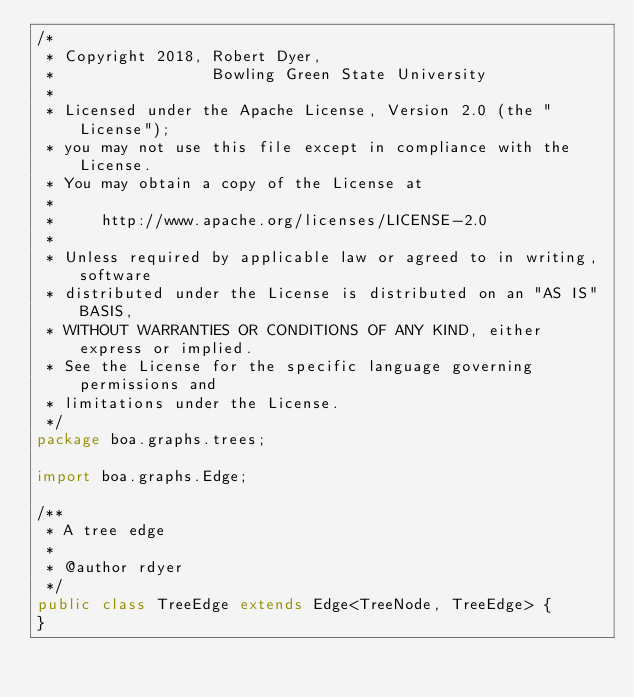<code> <loc_0><loc_0><loc_500><loc_500><_Java_>/*
 * Copyright 2018, Robert Dyer,
 *                 Bowling Green State University
 *
 * Licensed under the Apache License, Version 2.0 (the "License");
 * you may not use this file except in compliance with the License.
 * You may obtain a copy of the License at
 *
 *     http://www.apache.org/licenses/LICENSE-2.0
 *
 * Unless required by applicable law or agreed to in writing, software
 * distributed under the License is distributed on an "AS IS" BASIS,
 * WITHOUT WARRANTIES OR CONDITIONS OF ANY KIND, either express or implied.
 * See the License for the specific language governing permissions and
 * limitations under the License.
 */
package boa.graphs.trees;

import boa.graphs.Edge;

/**
 * A tree edge
 *
 * @author rdyer
 */
public class TreeEdge extends Edge<TreeNode, TreeEdge> {
}
</code> 